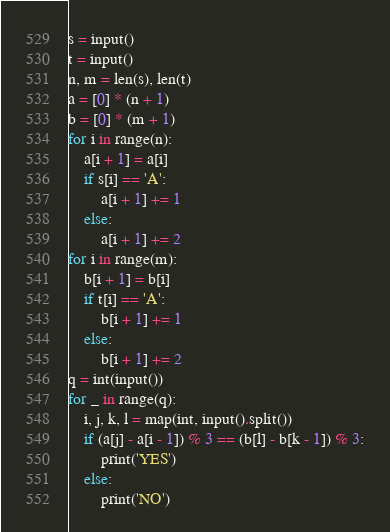Convert code to text. <code><loc_0><loc_0><loc_500><loc_500><_Python_>s = input()
t = input()
n, m = len(s), len(t)
a = [0] * (n + 1)
b = [0] * (m + 1)
for i in range(n):
    a[i + 1] = a[i]
    if s[i] == 'A':
        a[i + 1] += 1
    else:
        a[i + 1] += 2
for i in range(m):
    b[i + 1] = b[i]
    if t[i] == 'A':
        b[i + 1] += 1
    else:
        b[i + 1] += 2
q = int(input())
for _ in range(q):
    i, j, k, l = map(int, input().split())
    if (a[j] - a[i - 1]) % 3 == (b[l] - b[k - 1]) % 3:
        print('YES')
    else:
        print('NO')
</code> 